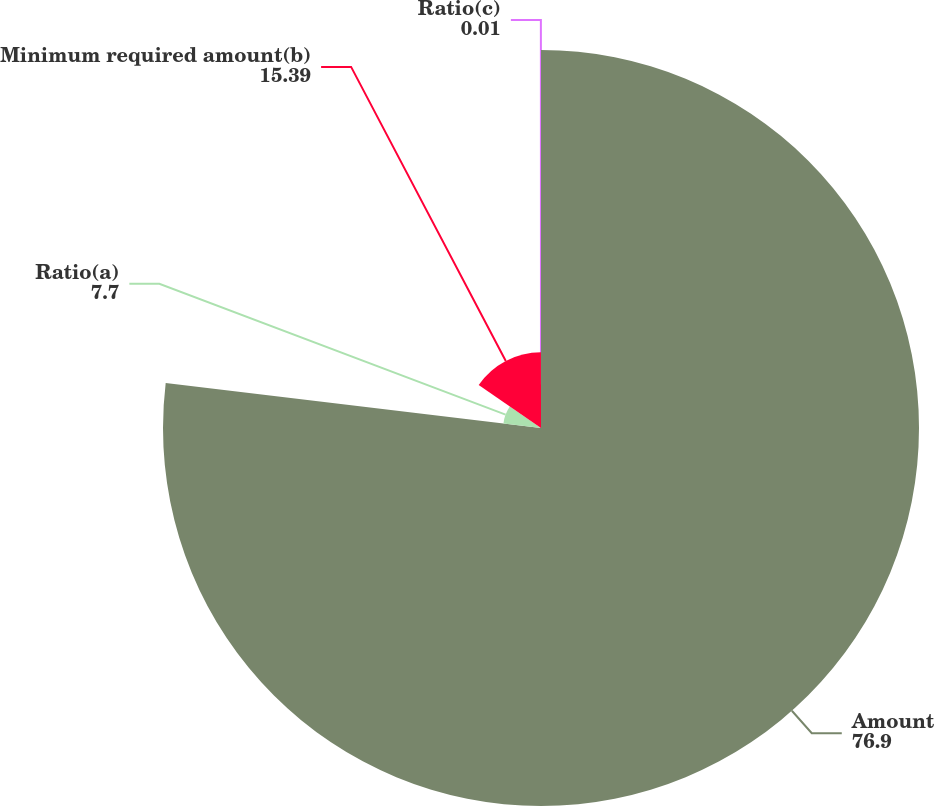Convert chart to OTSL. <chart><loc_0><loc_0><loc_500><loc_500><pie_chart><fcel>Amount<fcel>Ratio(a)<fcel>Minimum required amount(b)<fcel>Ratio(c)<nl><fcel>76.9%<fcel>7.7%<fcel>15.39%<fcel>0.01%<nl></chart> 